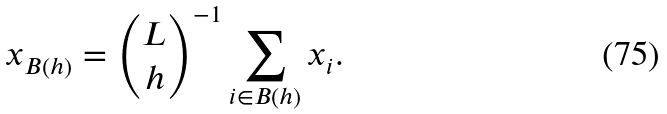Convert formula to latex. <formula><loc_0><loc_0><loc_500><loc_500>x _ { B ( h ) } = { L \choose h } ^ { - 1 } \sum _ { i \in B ( h ) } x _ { i } .</formula> 